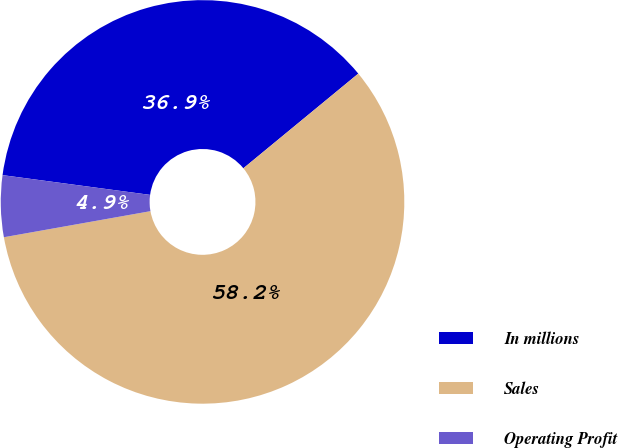Convert chart. <chart><loc_0><loc_0><loc_500><loc_500><pie_chart><fcel>In millions<fcel>Sales<fcel>Operating Profit<nl><fcel>36.92%<fcel>58.17%<fcel>4.92%<nl></chart> 